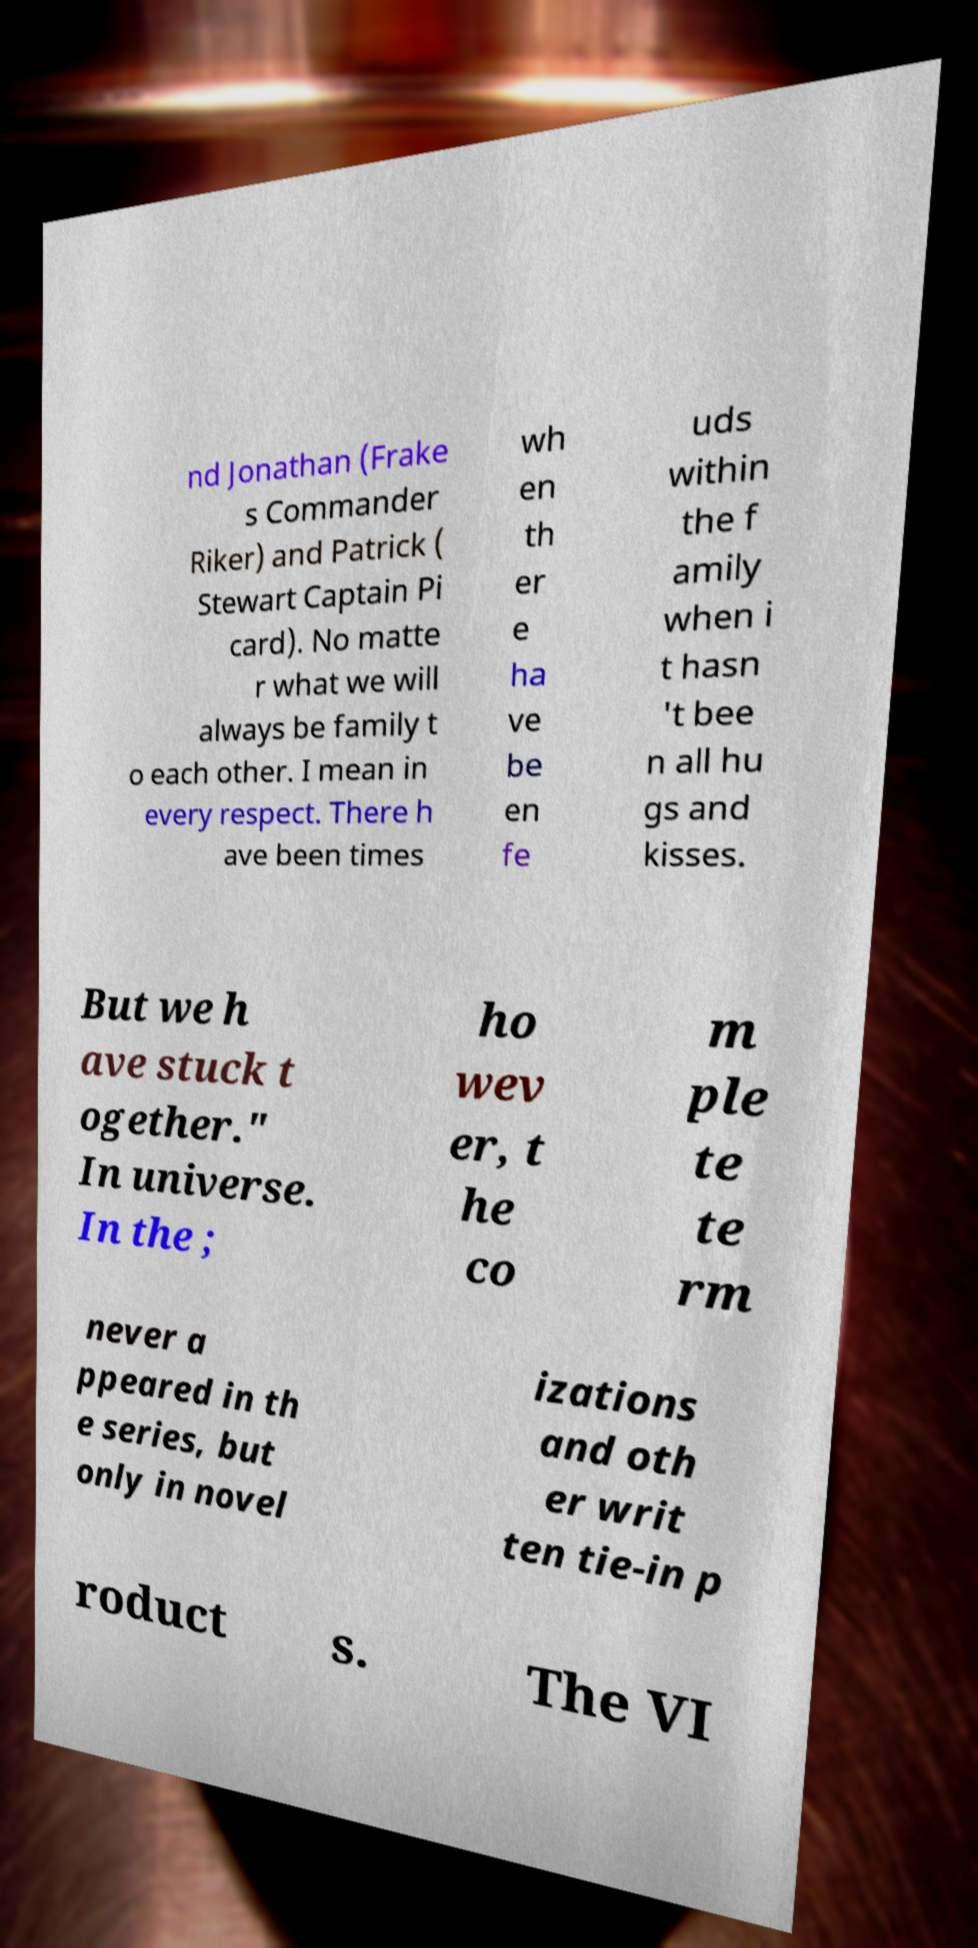Could you assist in decoding the text presented in this image and type it out clearly? nd Jonathan (Frake s Commander Riker) and Patrick ( Stewart Captain Pi card). No matte r what we will always be family t o each other. I mean in every respect. There h ave been times wh en th er e ha ve be en fe uds within the f amily when i t hasn 't bee n all hu gs and kisses. But we h ave stuck t ogether." In universe. In the ; ho wev er, t he co m ple te te rm never a ppeared in th e series, but only in novel izations and oth er writ ten tie-in p roduct s. The VI 